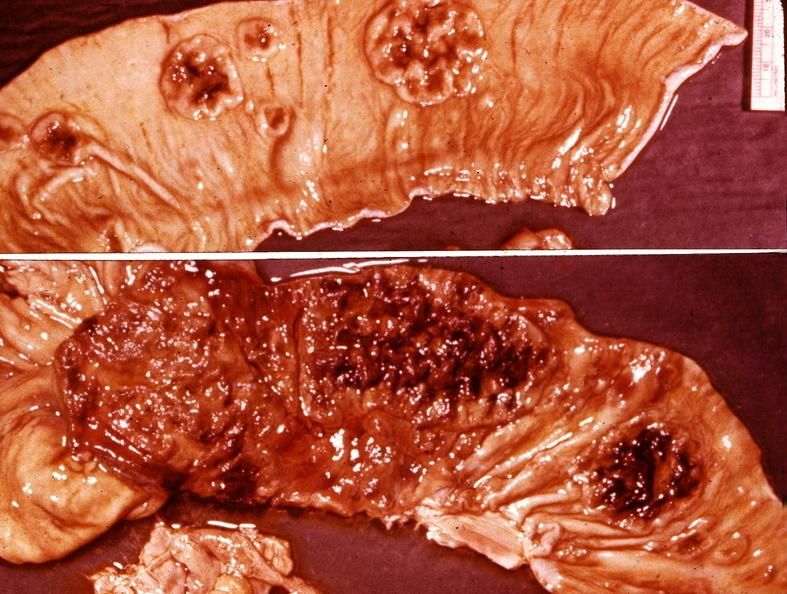does leg show small intestine, typhoid?
Answer the question using a single word or phrase. No 